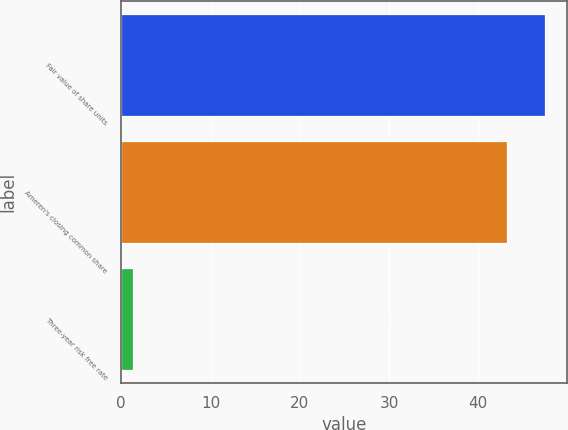Convert chart to OTSL. <chart><loc_0><loc_0><loc_500><loc_500><bar_chart><fcel>Fair value of share units<fcel>Ameren's closing common share<fcel>Three-year risk free rate<nl><fcel>47.51<fcel>43.23<fcel>1.31<nl></chart> 